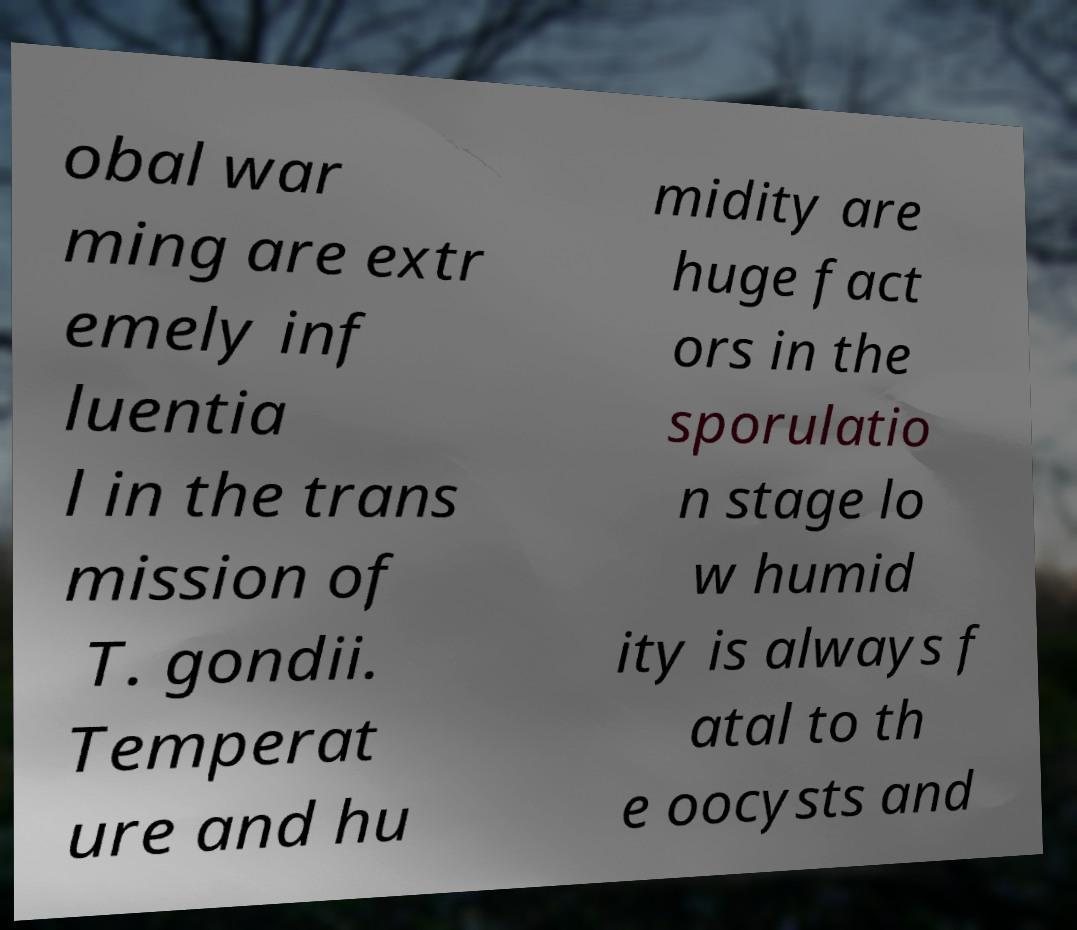Can you read and provide the text displayed in the image?This photo seems to have some interesting text. Can you extract and type it out for me? obal war ming are extr emely inf luentia l in the trans mission of T. gondii. Temperat ure and hu midity are huge fact ors in the sporulatio n stage lo w humid ity is always f atal to th e oocysts and 